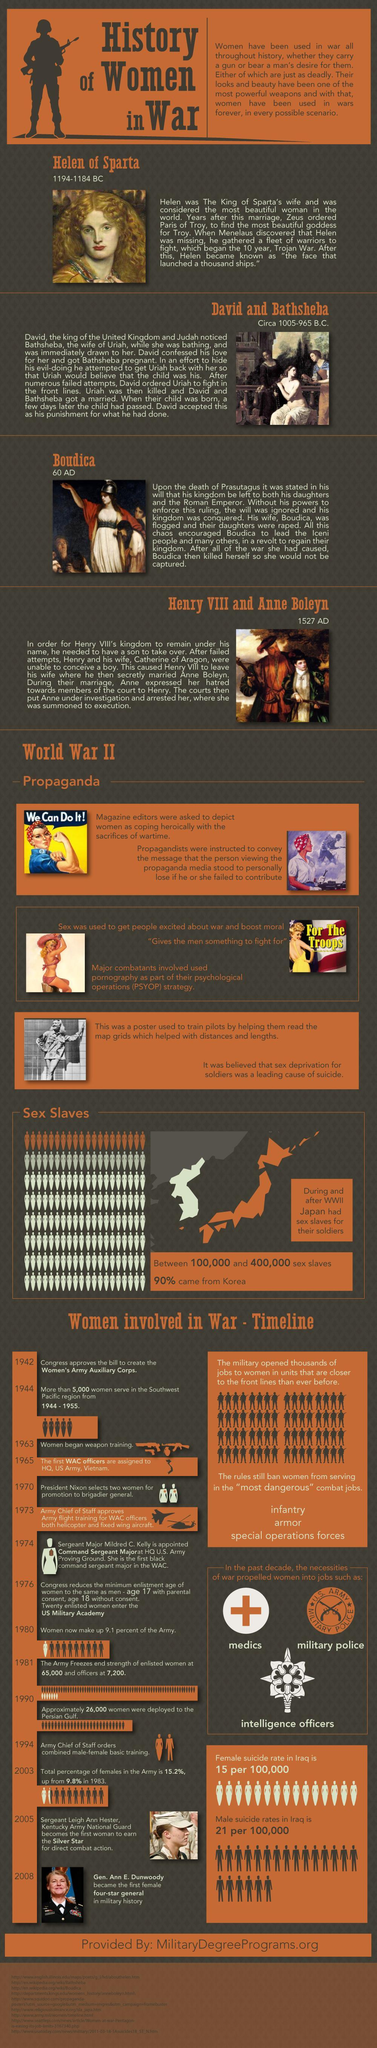when was Helen of Sparta died?
Answer the question with a short phrase. 1184 BC who is in the fourth section of this infographic? Henry VIII and Anne Boleyn whose suicide rate is higher in Iraq - men or women? men who is in the third section of this infographic? Boudica who is in the second section of this infographic? David and Bathsheba 